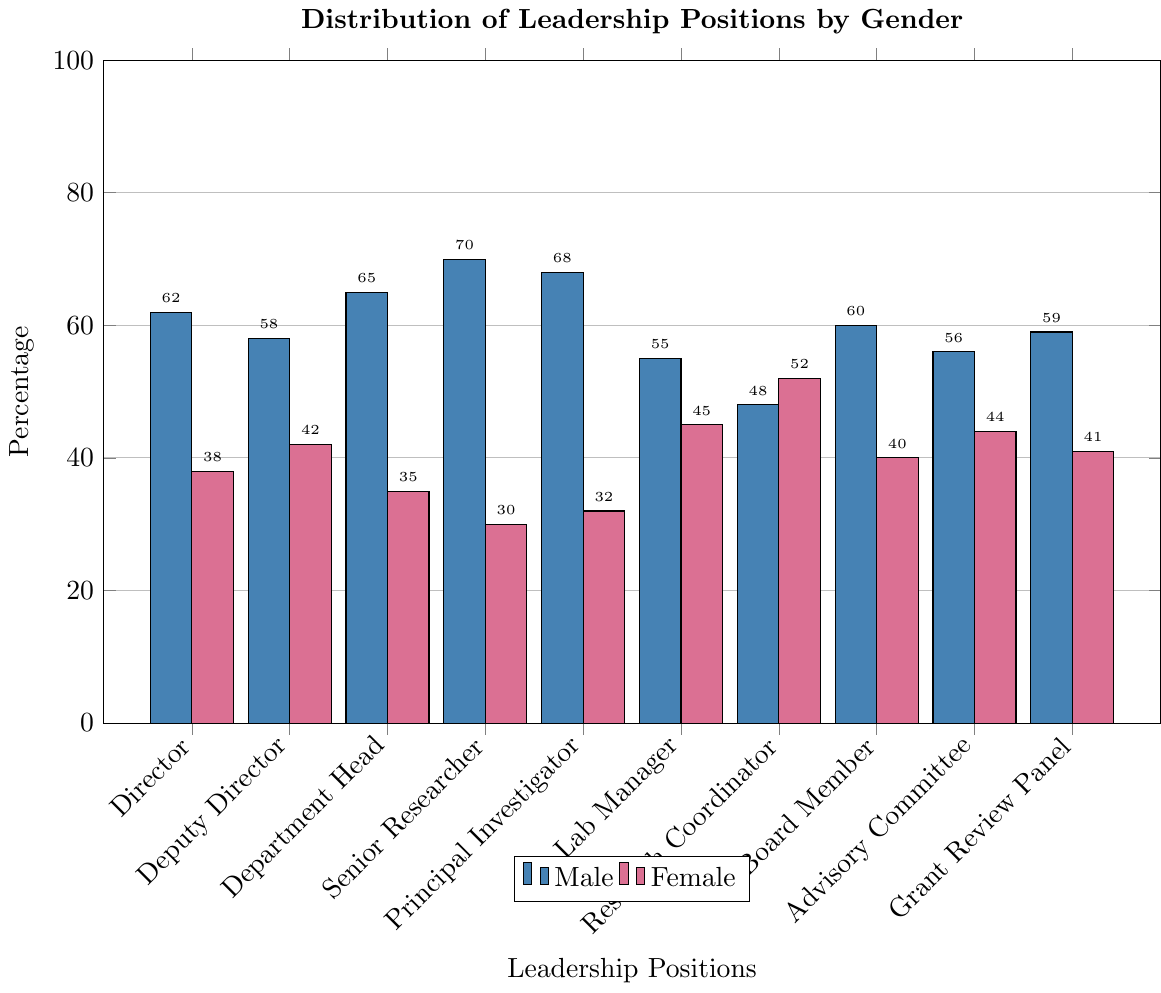What leadership position has the highest percentage of males? The bars representing males show the percentage values for each leadership position. "Senior Researcher" has the tallest bar at 70%.
Answer: Senior Researcher Which position has a greater percentage of females, Director or Lab Manager? Looking at the female bars for both positions, we see Director has a bar height of 38% while Lab Manager has a bar height of 45%. Thus, Lab Manager has a greater percentage of females.
Answer: Lab Manager What is the combined percentage of males in Director and Deputy Director positions? For the Director position, the male bar is at 62%. For the Deputy Director, it is at 58%. Adding these together gives 62% + 58% = 120%.
Answer: 120% By how much does the percentage of males in Principal Investigators exceed that of females? The percentage for males in Principal Investigators is 68% and for females, it is 32%. Subtracting these values gives 68% - 32% = 36%.
Answer: 36% What is the percentage difference between male and female Research Coordinators? The male percentage for Research Coordinators is 48% and the female percentage is 52%. The difference is 52% - 48% = 4%.
Answer: 4% Which position shows the smallest gender disparity? The gender disparity is smallest when the difference between male and female percentages is smallest. For 'Lab Manager,' the difference is 55% - 45% = 10%, which is the smallest among all positions.
Answer: Lab Manager What position has an equal number of females compared to males? None of the positions have an equal percentage of females and males.
Answer: None Compare the percentage of males in Senior Researcher to the female percentage in Board Member. The percentage of males in Senior Researcher is 70% while the percentage of females in Board Member is 40%. Thus, comparison shows 70% > 40%.
Answer: 70% > 40% What is the overall percentage of women in all depicted leadership positions averaged? Summing the female percentages: 38+42+35+30+32+45+52+40+44+41 = 399. There are 10 positions, so the average is 399/10 = 39.9%.
Answer: 39.9% What percentage of males are shown to be in the lowest represented leadership position for females? The lowest percentage for females is 30% in the Senior Researcher position. The corresponding male percentage for Senior Researcher is 70%.
Answer: 70% 